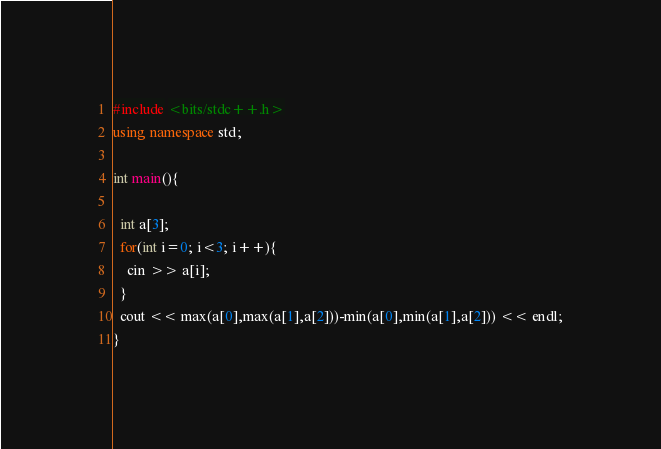<code> <loc_0><loc_0><loc_500><loc_500><_C++_>#include <bits/stdc++.h>
using namespace std;

int main(){

  int a[3];
  for(int i=0; i<3; i++){
	cin >> a[i];
  }
  cout << max(a[0],max(a[1],a[2]))-min(a[0],min(a[1],a[2])) << endl;
}</code> 